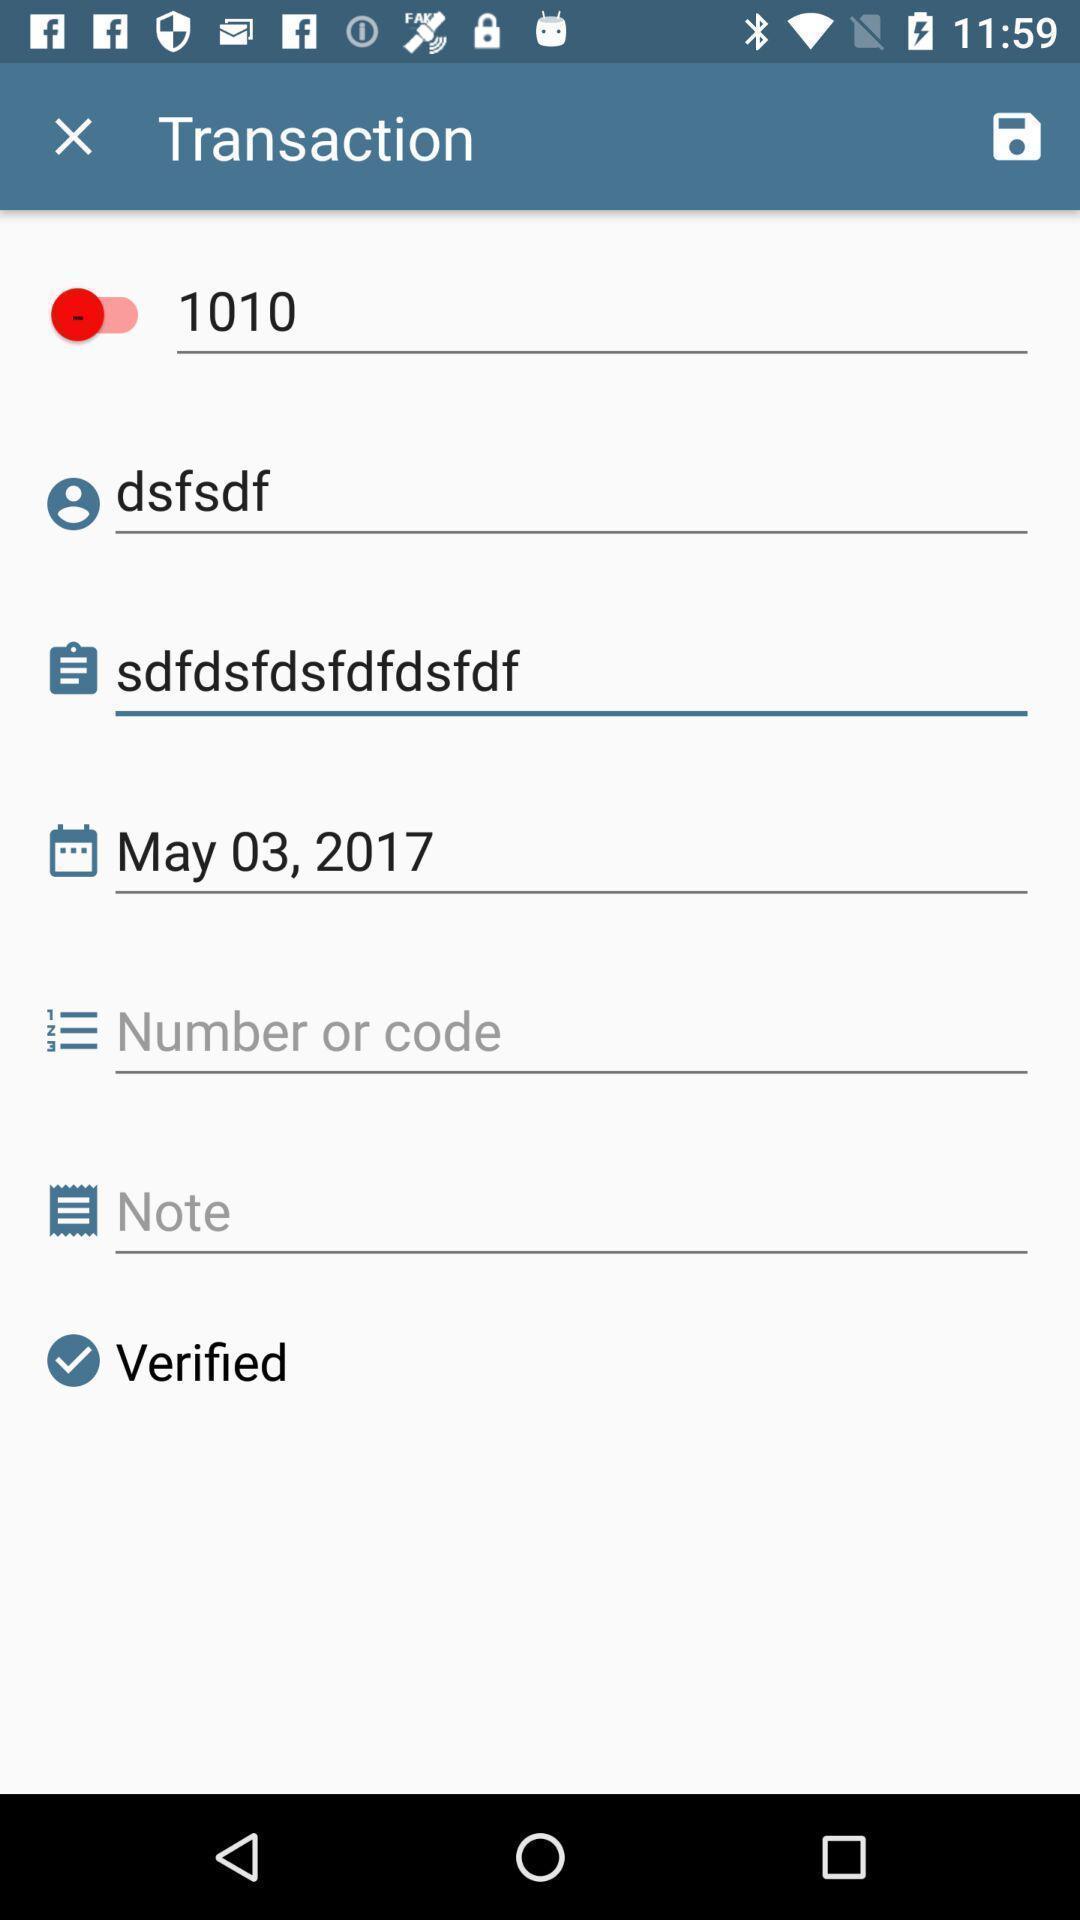Please provide a description for this image. Screen shows about a transaction. 